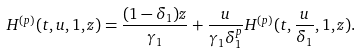<formula> <loc_0><loc_0><loc_500><loc_500>H ^ { ( p ) } ( t , u , 1 , z ) = \frac { ( 1 - \delta _ { 1 } ) z } { \gamma _ { 1 } } + \frac { u } { \gamma _ { 1 } \delta _ { 1 } ^ { p } } H ^ { ( p ) } ( t , \frac { u } { \delta _ { 1 } } , 1 , z ) .</formula> 